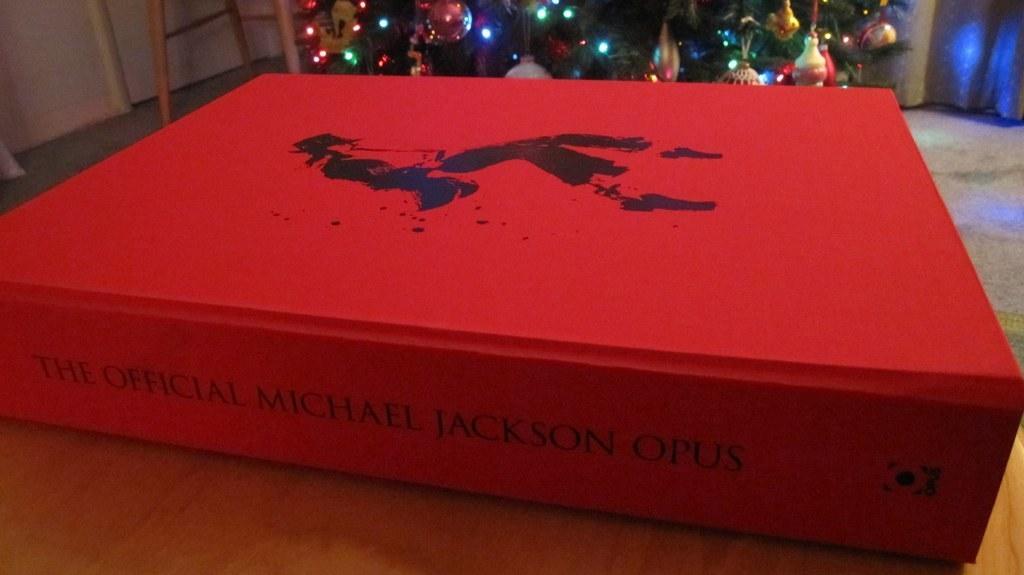In one or two sentences, can you explain what this image depicts? As we can see in the image there is a table, wall, ladder and Christmas tree. There are lights and decorative items. On table there is a red color book. On book there is something written. 